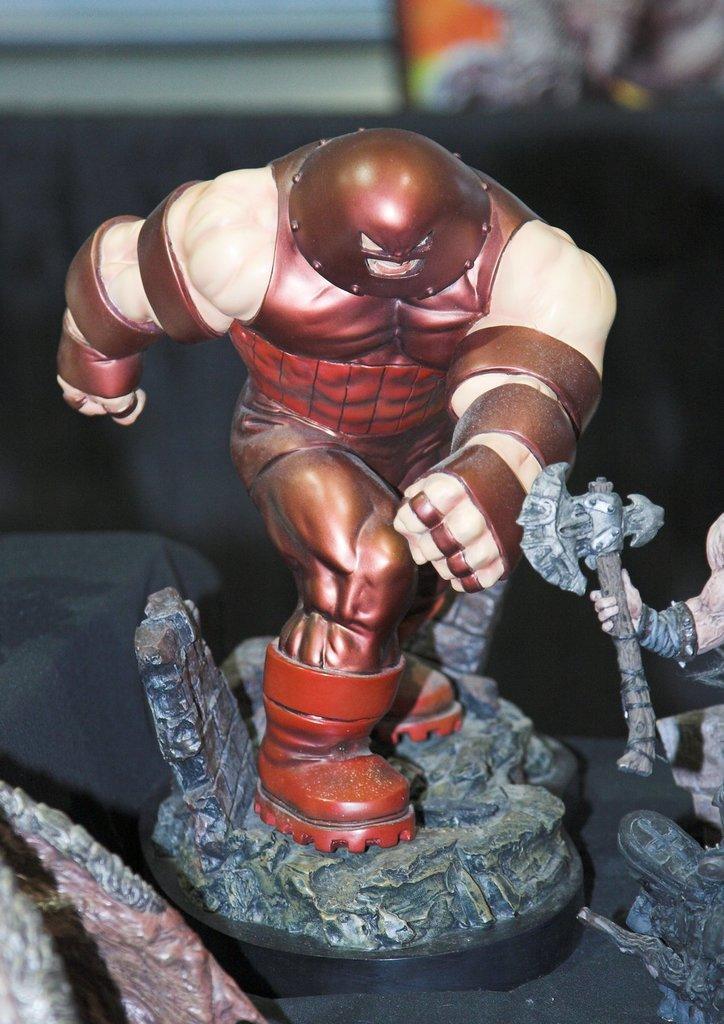Please provide a concise description of this image. In this picture I can observe a figurine of marvel character which is in brown and cream color. The background is blurred. 